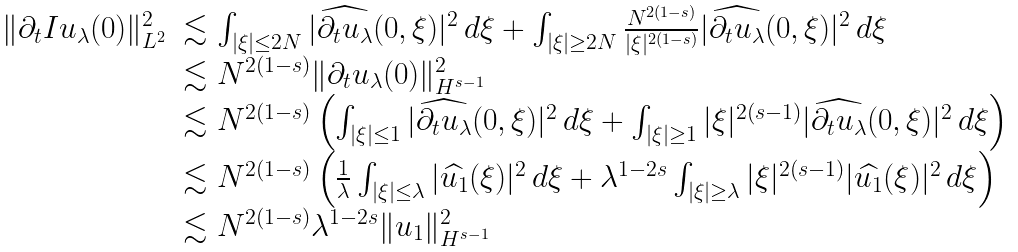Convert formula to latex. <formula><loc_0><loc_0><loc_500><loc_500>\begin{array} { l l } \| \partial _ { t } I u _ { \lambda } ( 0 ) \| ^ { 2 } _ { L ^ { 2 } } & \lesssim \int _ { | \xi | \leq 2 N } | \widehat { \partial _ { t } u _ { \lambda } } ( 0 , \xi ) | ^ { 2 } \, d \xi + \int _ { | \xi | \geq 2 N } \frac { N ^ { 2 ( 1 - s ) } } { | \xi | ^ { 2 ( 1 - s ) } } | \widehat { \partial _ { t } u _ { \lambda } } ( 0 , \xi ) | ^ { 2 } \, d \xi \\ & \lesssim N ^ { 2 ( 1 - s ) } \| \partial _ { t } u _ { \lambda } ( 0 ) \| ^ { 2 } _ { H ^ { s - 1 } } \\ & \lesssim N ^ { 2 ( 1 - s ) } \left ( \int _ { | \xi | \leq 1 } | \widehat { \partial _ { t } u _ { \lambda } } ( 0 , \xi ) | ^ { 2 } \, d \xi + \int _ { | \xi | \geq 1 } | \xi | ^ { 2 ( s - 1 ) } | \widehat { \partial _ { t } u _ { \lambda } } ( 0 , \xi ) | ^ { 2 } \, d \xi \right ) \\ & \lesssim N ^ { 2 ( 1 - s ) } \left ( \frac { 1 } { \lambda } \int _ { | \xi | \leq \lambda } | \widehat { u _ { 1 } } ( \xi ) | ^ { 2 } \, d \xi + \lambda ^ { 1 - 2 s } \int _ { | \xi | \geq \lambda } | \xi | ^ { 2 ( s - 1 ) } | \widehat { u _ { 1 } } ( \xi ) | ^ { 2 } \, d \xi \right ) \\ & \lesssim N ^ { 2 ( 1 - s ) } \lambda ^ { 1 - 2 s } \| u _ { 1 } \| ^ { 2 } _ { H ^ { s - 1 } } \end{array}</formula> 